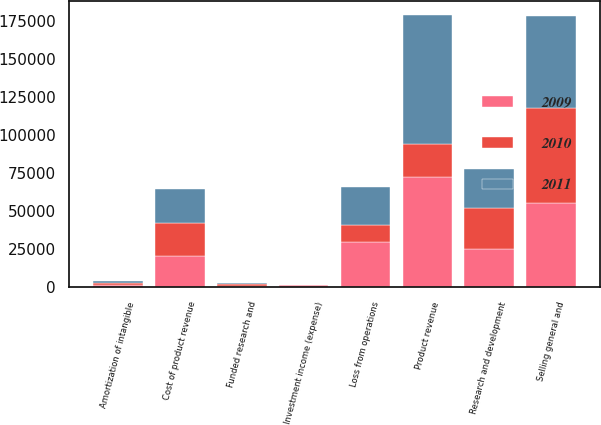Convert chart to OTSL. <chart><loc_0><loc_0><loc_500><loc_500><stacked_bar_chart><ecel><fcel>Product revenue<fcel>Funded research and<fcel>Cost of product revenue<fcel>Research and development<fcel>Selling general and<fcel>Amortization of intangible<fcel>Loss from operations<fcel>Investment income (expense)<nl><fcel>2010<fcel>21977<fcel>1314<fcel>21977<fcel>26677<fcel>62287<fcel>1395<fcel>11185<fcel>9<nl><fcel>2011<fcel>84765<fcel>948<fcel>22529<fcel>25954<fcel>60837<fcel>1469<fcel>25076<fcel>373<nl><fcel>2009<fcel>72512<fcel>698<fcel>20437<fcel>25328<fcel>55357<fcel>1606<fcel>29518<fcel>1404<nl></chart> 